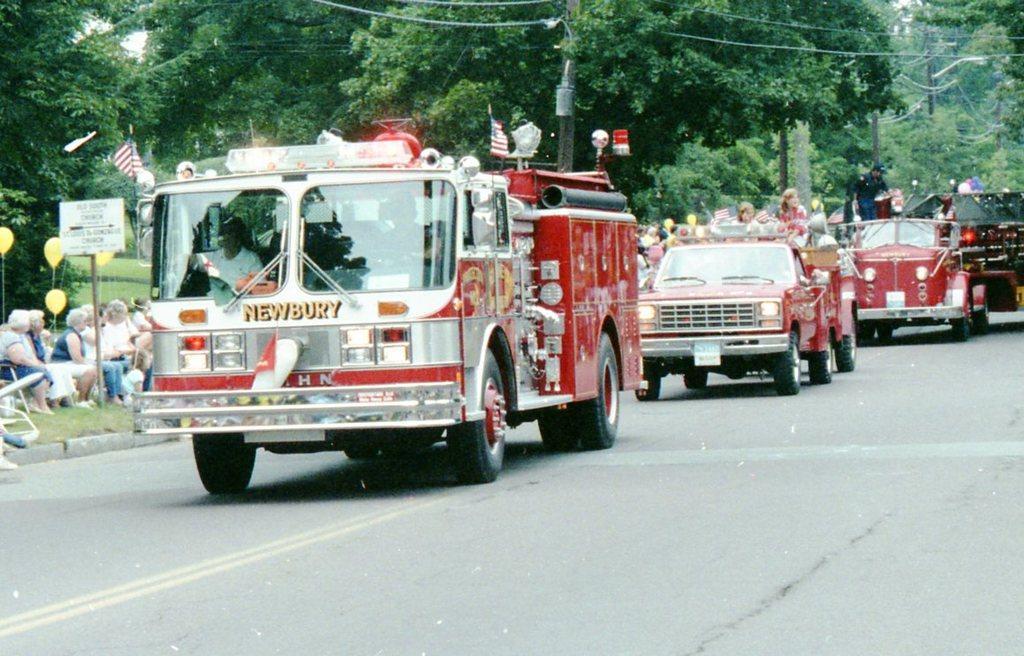Please provide a concise description of this image. In this image at the bottom there is a road on the road there are some vehicles and in the vehicles there are some people who are sitting, and on the left side there are a group of people who are sitting and also there are some trees poles and wires 